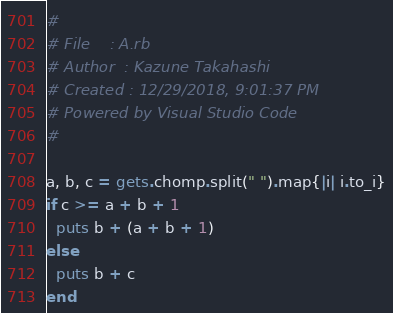<code> <loc_0><loc_0><loc_500><loc_500><_Ruby_>#
# File    : A.rb
# Author  : Kazune Takahashi
# Created : 12/29/2018, 9:01:37 PM
# Powered by Visual Studio Code
#

a, b, c = gets.chomp.split(" ").map{|i| i.to_i}
if c >= a + b + 1
  puts b + (a + b + 1)
else
  puts b + c
end
</code> 